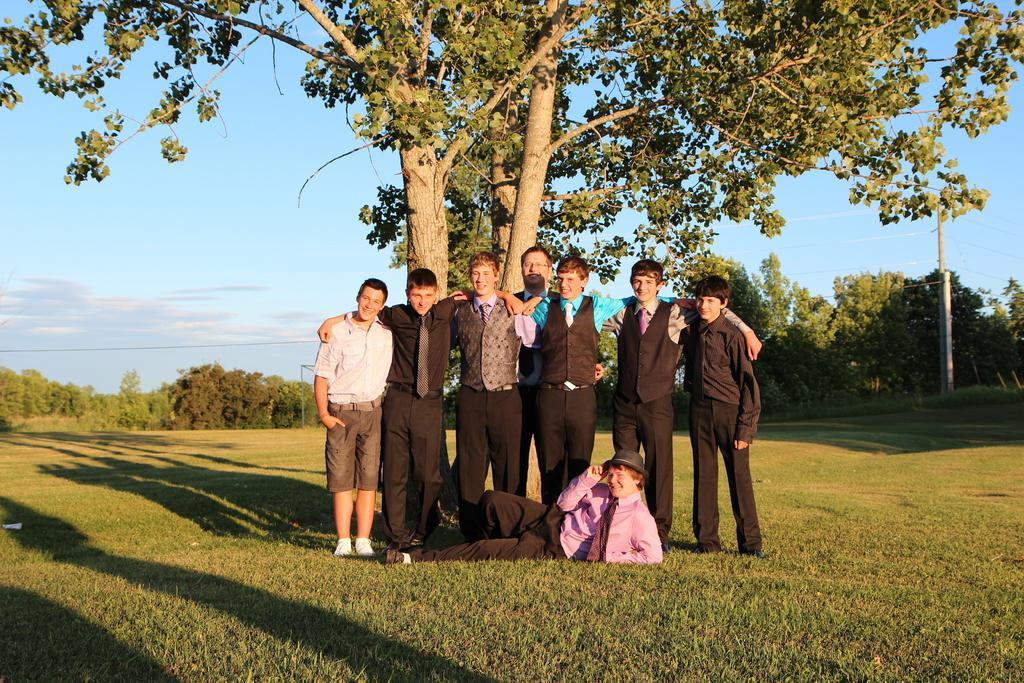How would you summarize this image in a sentence or two? In the picture I can see few persons standing on a greenery ground and there is a person lying on the greenery ground in front of them and there are few trees in the background and there is a pole in the right corner. 